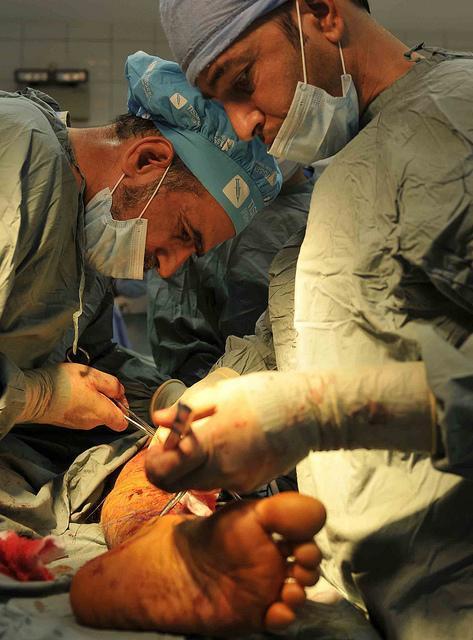How many people can you see?
Give a very brief answer. 4. How many suitcases are there?
Give a very brief answer. 0. 